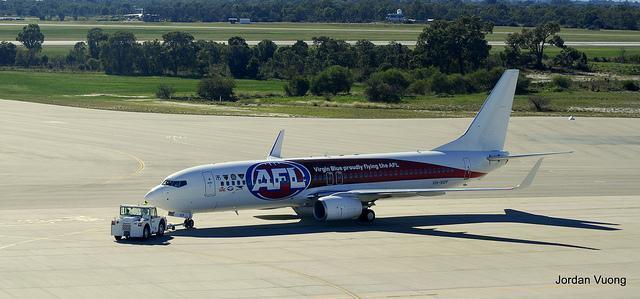How many orange lights can you see on the motorcycle?
Give a very brief answer. 0. 